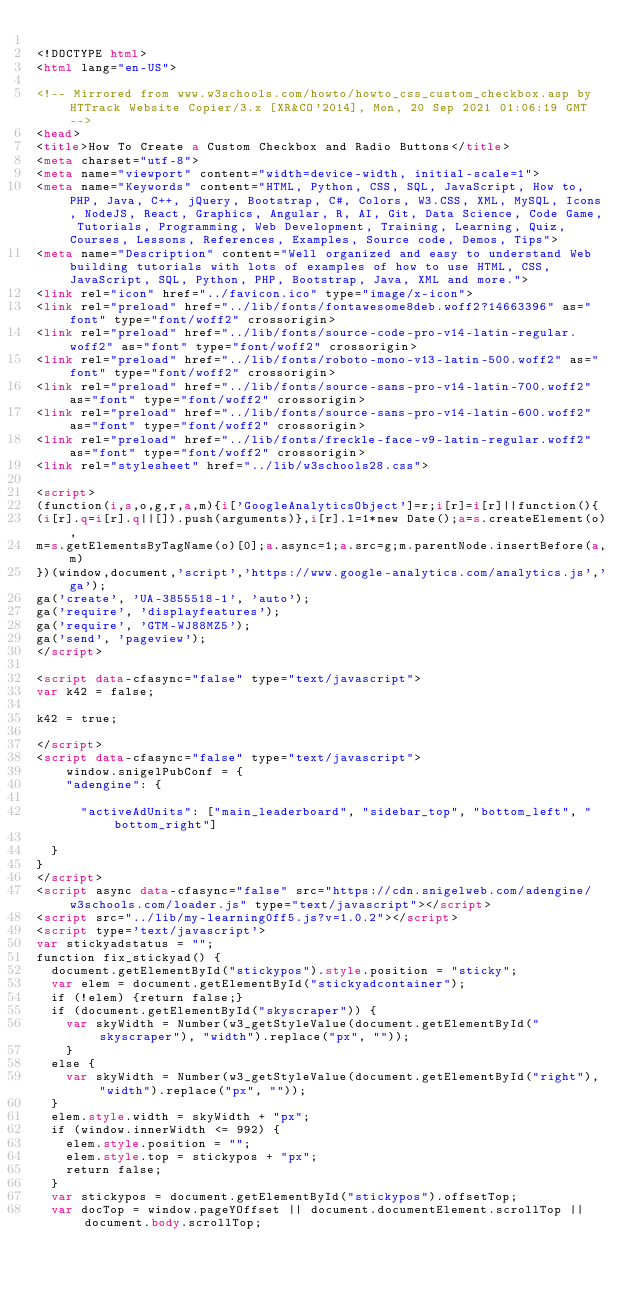<code> <loc_0><loc_0><loc_500><loc_500><_HTML_>
<!DOCTYPE html>
<html lang="en-US">

<!-- Mirrored from www.w3schools.com/howto/howto_css_custom_checkbox.asp by HTTrack Website Copier/3.x [XR&CO'2014], Mon, 20 Sep 2021 01:06:19 GMT -->
<head>
<title>How To Create a Custom Checkbox and Radio Buttons</title>
<meta charset="utf-8">
<meta name="viewport" content="width=device-width, initial-scale=1">
<meta name="Keywords" content="HTML, Python, CSS, SQL, JavaScript, How to, PHP, Java, C++, jQuery, Bootstrap, C#, Colors, W3.CSS, XML, MySQL, Icons, NodeJS, React, Graphics, Angular, R, AI, Git, Data Science, Code Game, Tutorials, Programming, Web Development, Training, Learning, Quiz, Courses, Lessons, References, Examples, Source code, Demos, Tips">
<meta name="Description" content="Well organized and easy to understand Web building tutorials with lots of examples of how to use HTML, CSS, JavaScript, SQL, Python, PHP, Bootstrap, Java, XML and more.">
<link rel="icon" href="../favicon.ico" type="image/x-icon">
<link rel="preload" href="../lib/fonts/fontawesome8deb.woff2?14663396" as="font" type="font/woff2" crossorigin> 
<link rel="preload" href="../lib/fonts/source-code-pro-v14-latin-regular.woff2" as="font" type="font/woff2" crossorigin> 
<link rel="preload" href="../lib/fonts/roboto-mono-v13-latin-500.woff2" as="font" type="font/woff2" crossorigin> 
<link rel="preload" href="../lib/fonts/source-sans-pro-v14-latin-700.woff2" as="font" type="font/woff2" crossorigin> 
<link rel="preload" href="../lib/fonts/source-sans-pro-v14-latin-600.woff2" as="font" type="font/woff2" crossorigin> 
<link rel="preload" href="../lib/fonts/freckle-face-v9-latin-regular.woff2" as="font" type="font/woff2" crossorigin> 
<link rel="stylesheet" href="../lib/w3schools28.css">

<script>
(function(i,s,o,g,r,a,m){i['GoogleAnalyticsObject']=r;i[r]=i[r]||function(){
(i[r].q=i[r].q||[]).push(arguments)},i[r].l=1*new Date();a=s.createElement(o),
m=s.getElementsByTagName(o)[0];a.async=1;a.src=g;m.parentNode.insertBefore(a,m)
})(window,document,'script','https://www.google-analytics.com/analytics.js','ga');
ga('create', 'UA-3855518-1', 'auto');
ga('require', 'displayfeatures');
ga('require', 'GTM-WJ88MZ5');
ga('send', 'pageview');
</script>

<script data-cfasync="false" type="text/javascript">
var k42 = false;

k42 = true;

</script>
<script data-cfasync="false" type="text/javascript">
    window.snigelPubConf = {
    "adengine": {

      "activeAdUnits": ["main_leaderboard", "sidebar_top", "bottom_left", "bottom_right"]

  }
}
</script>
<script async data-cfasync="false" src="https://cdn.snigelweb.com/adengine/w3schools.com/loader.js" type="text/javascript"></script>
<script src="../lib/my-learning0ff5.js?v=1.0.2"></script>
<script type='text/javascript'>
var stickyadstatus = "";
function fix_stickyad() {
  document.getElementById("stickypos").style.position = "sticky";
  var elem = document.getElementById("stickyadcontainer");
  if (!elem) {return false;}
  if (document.getElementById("skyscraper")) {
    var skyWidth = Number(w3_getStyleValue(document.getElementById("skyscraper"), "width").replace("px", ""));  
    }
  else {
    var skyWidth = Number(w3_getStyleValue(document.getElementById("right"), "width").replace("px", ""));  
  }
  elem.style.width = skyWidth + "px";
  if (window.innerWidth <= 992) {
    elem.style.position = "";
    elem.style.top = stickypos + "px";
    return false;
  }
  var stickypos = document.getElementById("stickypos").offsetTop;
  var docTop = window.pageYOffset || document.documentElement.scrollTop || document.body.scrollTop;</code> 